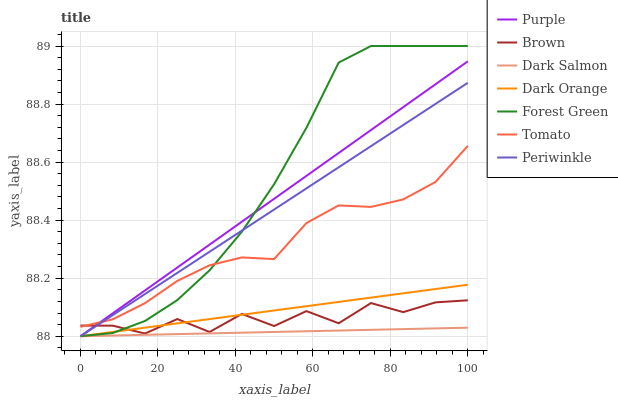Does Brown have the minimum area under the curve?
Answer yes or no. No. Does Brown have the maximum area under the curve?
Answer yes or no. No. Is Dark Orange the smoothest?
Answer yes or no. No. Is Dark Orange the roughest?
Answer yes or no. No. Does Brown have the lowest value?
Answer yes or no. No. Does Brown have the highest value?
Answer yes or no. No. Is Dark Salmon less than Brown?
Answer yes or no. Yes. Is Tomato greater than Dark Orange?
Answer yes or no. Yes. Does Dark Salmon intersect Brown?
Answer yes or no. No. 